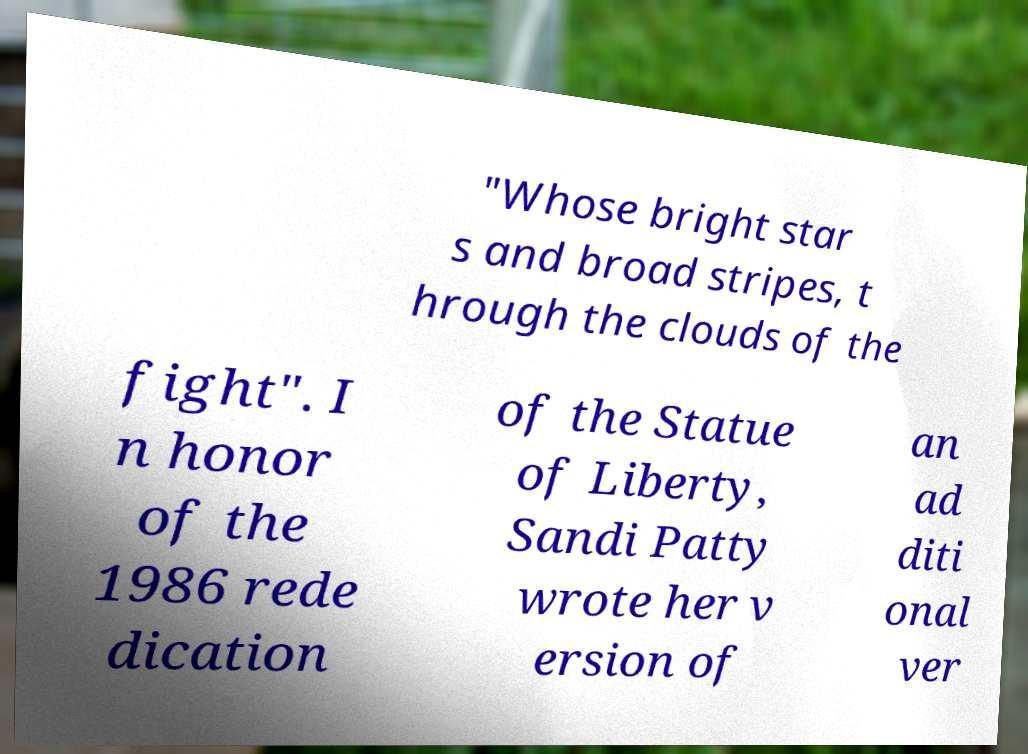I need the written content from this picture converted into text. Can you do that? "Whose bright star s and broad stripes, t hrough the clouds of the fight". I n honor of the 1986 rede dication of the Statue of Liberty, Sandi Patty wrote her v ersion of an ad diti onal ver 